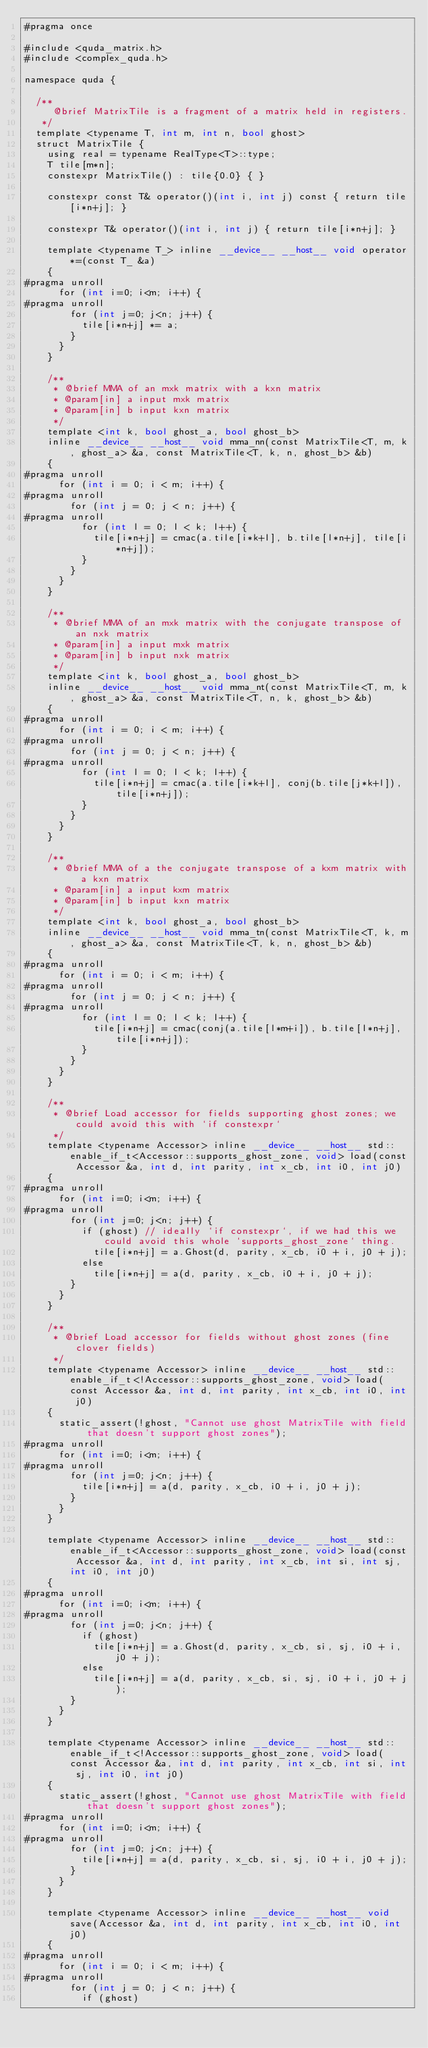<code> <loc_0><loc_0><loc_500><loc_500><_Cuda_>#pragma once

#include <quda_matrix.h>
#include <complex_quda.h>

namespace quda {

  /**
     @brief MatrixTile is a fragment of a matrix held in registers.
   */
  template <typename T, int m, int n, bool ghost>
  struct MatrixTile {
    using real = typename RealType<T>::type;
    T tile[m*n];
    constexpr MatrixTile() : tile{0.0} { }

    constexpr const T& operator()(int i, int j) const { return tile[i*n+j]; }

    constexpr T& operator()(int i, int j) { return tile[i*n+j]; }

    template <typename T_> inline __device__ __host__ void operator*=(const T_ &a)
    {
#pragma unroll
      for (int i=0; i<m; i++) {
#pragma unroll
        for (int j=0; j<n; j++) {
          tile[i*n+j] *= a;
        }
      }
    }

    /**
     * @brief MMA of an mxk matrix with a kxn matrix
     * @param[in] a input mxk matrix
     * @param[in] b input kxn matrix
     */
    template <int k, bool ghost_a, bool ghost_b>
    inline __device__ __host__ void mma_nn(const MatrixTile<T, m, k, ghost_a> &a, const MatrixTile<T, k, n, ghost_b> &b)
    {
#pragma unroll
      for (int i = 0; i < m; i++) {
#pragma unroll
        for (int j = 0; j < n; j++) {
#pragma unroll
          for (int l = 0; l < k; l++) {
            tile[i*n+j] = cmac(a.tile[i*k+l], b.tile[l*n+j], tile[i*n+j]);
          }
        }
      }
    }

    /**
     * @brief MMA of an mxk matrix with the conjugate transpose of an nxk matrix
     * @param[in] a input mxk matrix
     * @param[in] b input nxk matrix
     */
    template <int k, bool ghost_a, bool ghost_b>
    inline __device__ __host__ void mma_nt(const MatrixTile<T, m, k, ghost_a> &a, const MatrixTile<T, n, k, ghost_b> &b)
    {
#pragma unroll
      for (int i = 0; i < m; i++) {
#pragma unroll
        for (int j = 0; j < n; j++) {
#pragma unroll
          for (int l = 0; l < k; l++) {
            tile[i*n+j] = cmac(a.tile[i*k+l], conj(b.tile[j*k+l]), tile[i*n+j]);
          }
        }
      }
    }

    /**
     * @brief MMA of a the conjugate transpose of a kxm matrix with a kxn matrix
     * @param[in] a input kxm matrix
     * @param[in] b input kxn matrix
     */
    template <int k, bool ghost_a, bool ghost_b>
    inline __device__ __host__ void mma_tn(const MatrixTile<T, k, m, ghost_a> &a, const MatrixTile<T, k, n, ghost_b> &b)
    {
#pragma unroll
      for (int i = 0; i < m; i++) {
#pragma unroll
        for (int j = 0; j < n; j++) {
#pragma unroll
          for (int l = 0; l < k; l++) {
            tile[i*n+j] = cmac(conj(a.tile[l*m+i]), b.tile[l*n+j], tile[i*n+j]);
          }
        }
      }
    }

    /**
     * @brief Load accessor for fields supporting ghost zones; we could avoid this with `if constexpr`
     */
    template <typename Accessor> inline __device__ __host__ std::enable_if_t<Accessor::supports_ghost_zone, void> load(const Accessor &a, int d, int parity, int x_cb, int i0, int j0)
    {
#pragma unroll
      for (int i=0; i<m; i++) {
#pragma unroll
        for (int j=0; j<n; j++) {
          if (ghost) // ideally `if constexpr`, if we had this we could avoid this whole `supports_ghost_zone` thing.
            tile[i*n+j] = a.Ghost(d, parity, x_cb, i0 + i, j0 + j);
          else
            tile[i*n+j] = a(d, parity, x_cb, i0 + i, j0 + j);
        }
      }
    }

    /**
     * @brief Load accessor for fields without ghost zones (fine clover fields)
     */
    template <typename Accessor> inline __device__ __host__ std::enable_if_t<!Accessor::supports_ghost_zone, void> load(const Accessor &a, int d, int parity, int x_cb, int i0, int j0)
    {
      static_assert(!ghost, "Cannot use ghost MatrixTile with field that doesn't support ghost zones");
#pragma unroll
      for (int i=0; i<m; i++) {
#pragma unroll
        for (int j=0; j<n; j++) {
          tile[i*n+j] = a(d, parity, x_cb, i0 + i, j0 + j);
        }
      }
    }

    template <typename Accessor> inline __device__ __host__ std::enable_if_t<Accessor::supports_ghost_zone, void> load(const Accessor &a, int d, int parity, int x_cb, int si, int sj, int i0, int j0)
    {
#pragma unroll
      for (int i=0; i<m; i++) {
#pragma unroll
        for (int j=0; j<n; j++) {
          if (ghost)
            tile[i*n+j] = a.Ghost(d, parity, x_cb, si, sj, i0 + i, j0 + j);
          else
            tile[i*n+j] = a(d, parity, x_cb, si, sj, i0 + i, j0 + j);
        }
      }
    }

    template <typename Accessor> inline __device__ __host__ std::enable_if_t<!Accessor::supports_ghost_zone, void> load(const Accessor &a, int d, int parity, int x_cb, int si, int sj, int i0, int j0)
    {
      static_assert(!ghost, "Cannot use ghost MatrixTile with field that doesn't support ghost zones");
#pragma unroll
      for (int i=0; i<m; i++) {
#pragma unroll
        for (int j=0; j<n; j++) {
          tile[i*n+j] = a(d, parity, x_cb, si, sj, i0 + i, j0 + j);
        }
      }
    }

    template <typename Accessor> inline __device__ __host__ void save(Accessor &a, int d, int parity, int x_cb, int i0, int j0)
    {
#pragma unroll
      for (int i = 0; i < m; i++) {
#pragma unroll
        for (int j = 0; j < n; j++) {
          if (ghost)</code> 